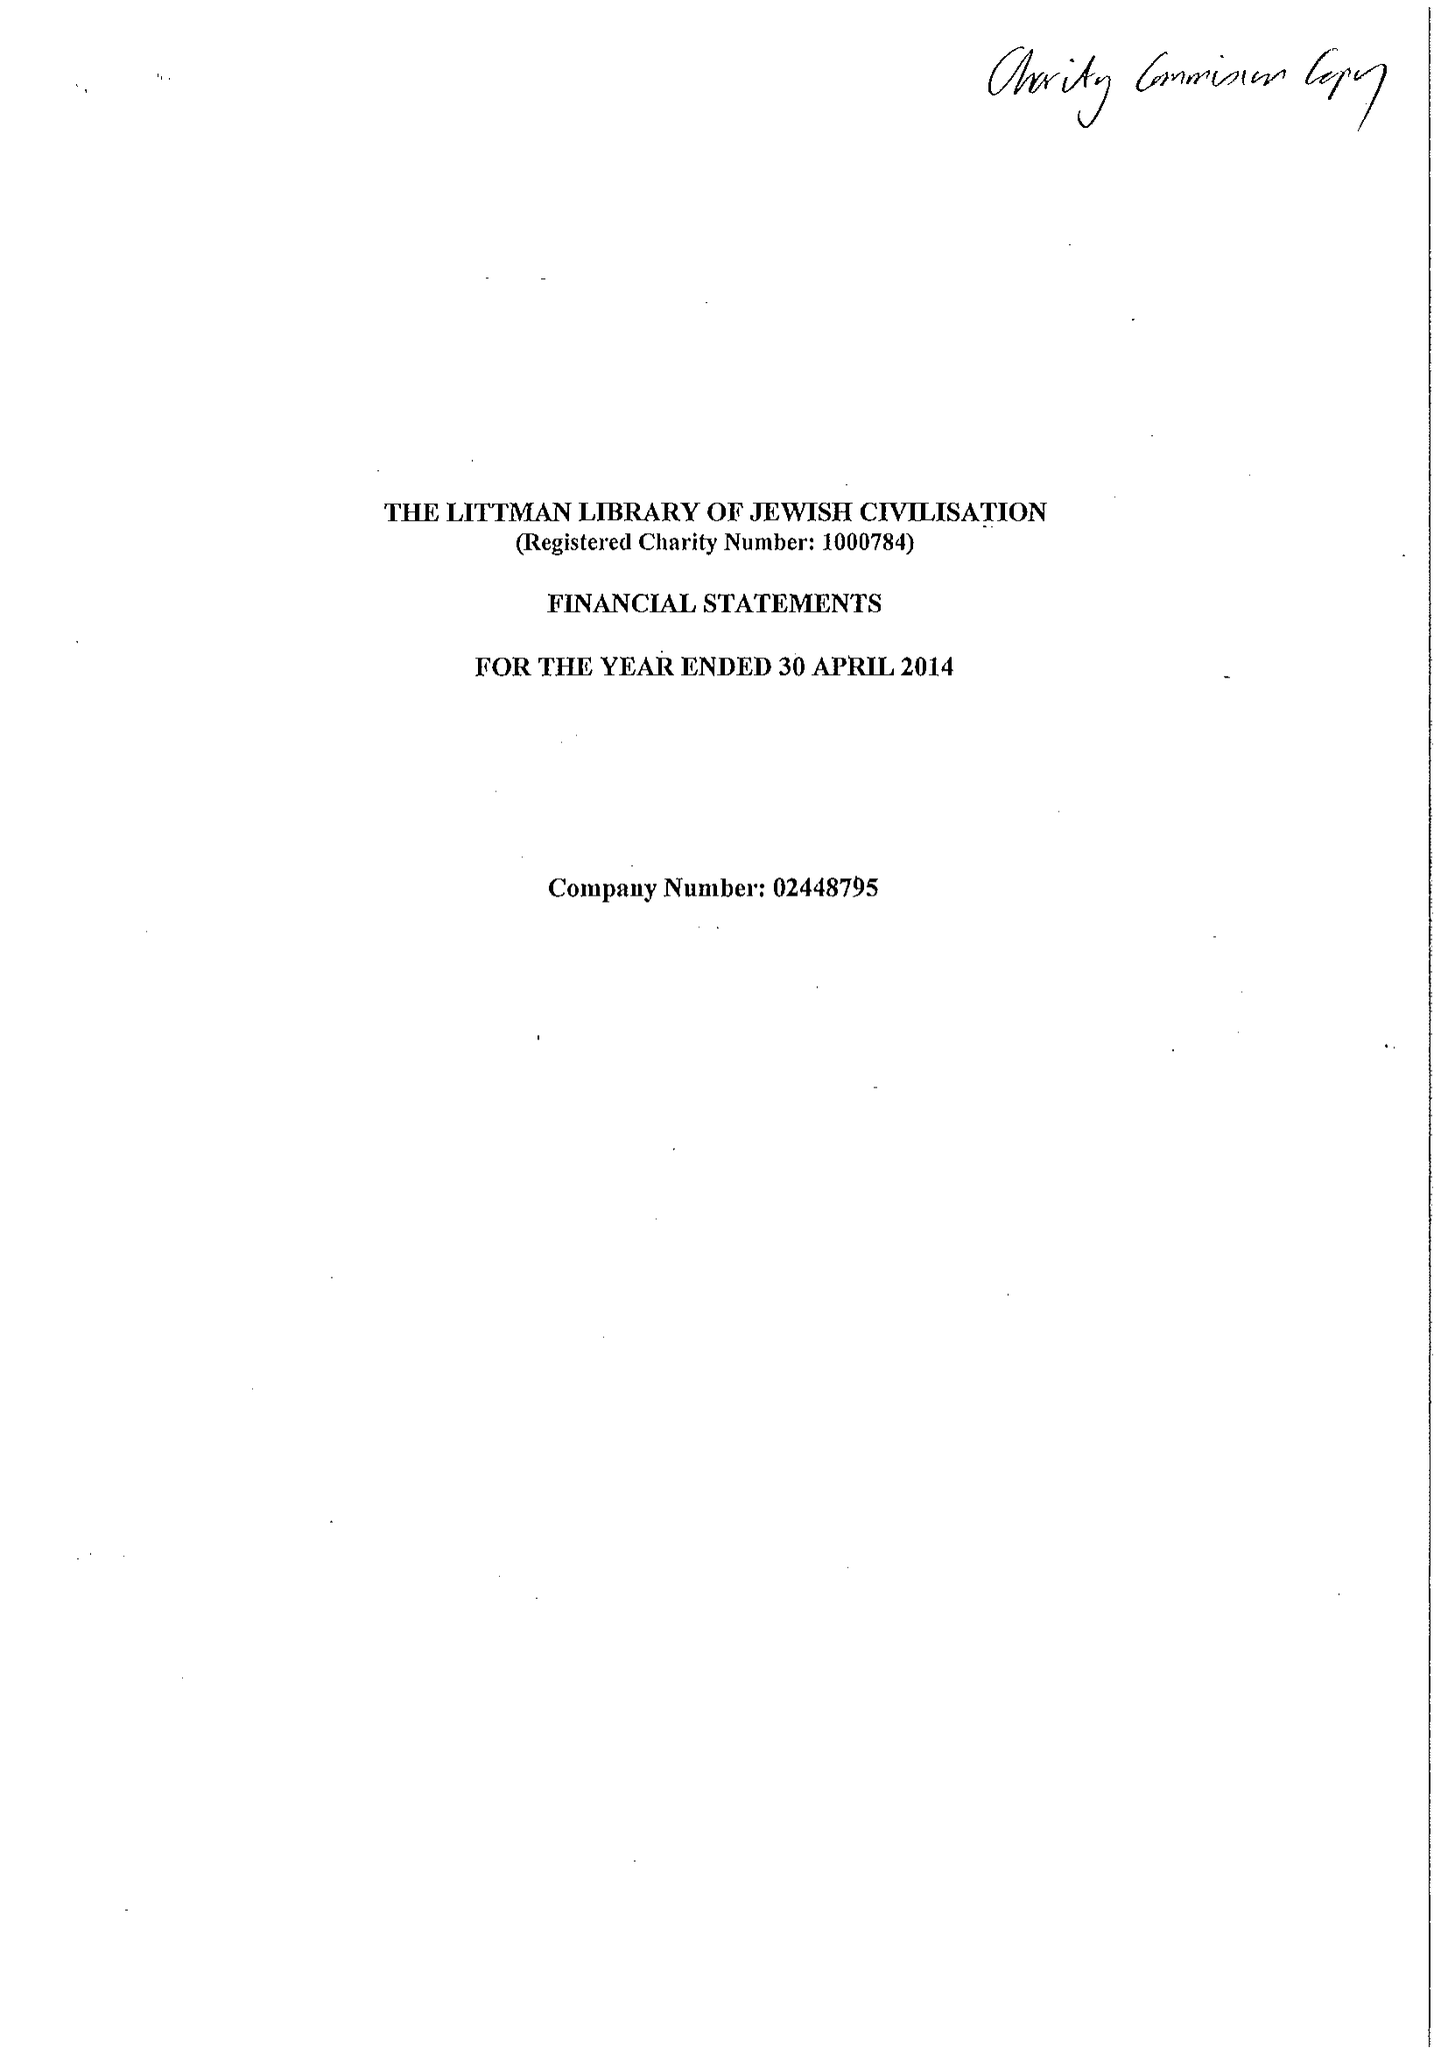What is the value for the report_date?
Answer the question using a single word or phrase. 2014-04-30 